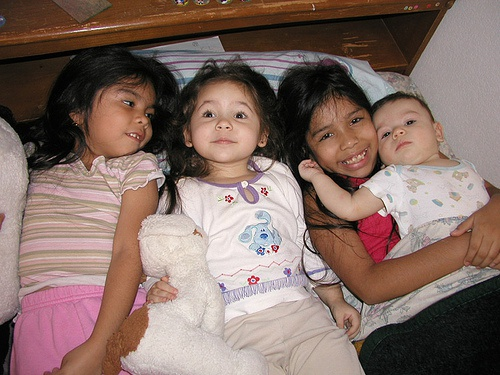Describe the objects in this image and their specific colors. I can see bed in black, lightgray, brown, and darkgray tones, people in black, brown, lightpink, and darkgray tones, people in black, lightgray, darkgray, and tan tones, people in black and brown tones, and people in black, lightgray, darkgray, and tan tones in this image. 